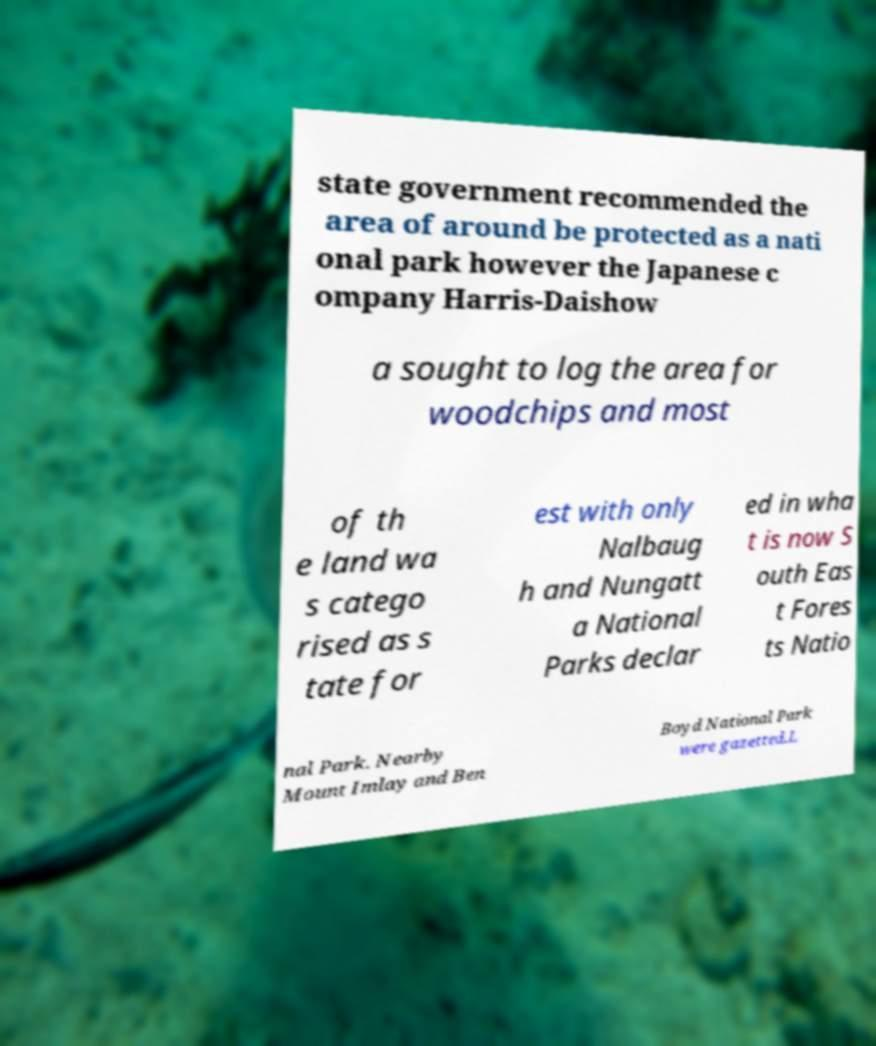What messages or text are displayed in this image? I need them in a readable, typed format. state government recommended the area of around be protected as a nati onal park however the Japanese c ompany Harris-Daishow a sought to log the area for woodchips and most of th e land wa s catego rised as s tate for est with only Nalbaug h and Nungatt a National Parks declar ed in wha t is now S outh Eas t Fores ts Natio nal Park. Nearby Mount Imlay and Ben Boyd National Park were gazetted.L 